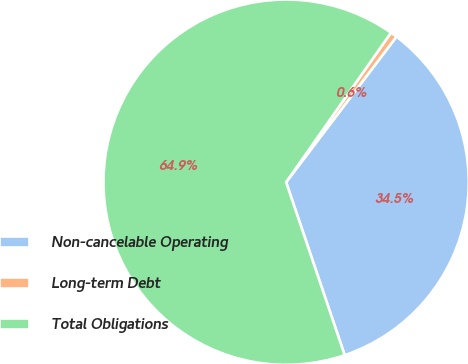Convert chart. <chart><loc_0><loc_0><loc_500><loc_500><pie_chart><fcel>Non-cancelable Operating<fcel>Long-term Debt<fcel>Total Obligations<nl><fcel>34.48%<fcel>0.59%<fcel>64.94%<nl></chart> 